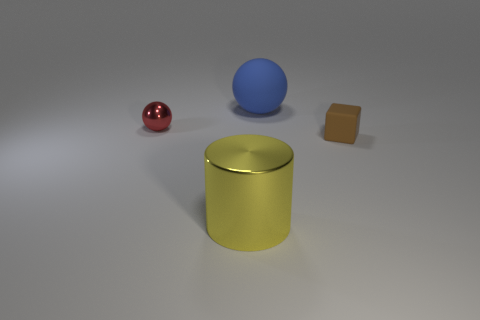What number of metal things are either big blue spheres or big yellow objects?
Your answer should be compact. 1. There is a sphere that is on the right side of the metal object behind the tiny block; what is it made of?
Provide a short and direct response. Rubber. What is the size of the yellow metal object?
Provide a short and direct response. Large. How many yellow shiny objects are the same size as the blue thing?
Your answer should be compact. 1. How many yellow things are the same shape as the brown thing?
Provide a succinct answer. 0. Is the number of large yellow shiny objects in front of the cylinder the same as the number of metallic spheres?
Ensure brevity in your answer.  No. Is there any other thing that has the same size as the blue matte thing?
Offer a terse response. Yes. What shape is the blue object that is the same size as the yellow cylinder?
Keep it short and to the point. Sphere. Is there a large green thing of the same shape as the small brown rubber object?
Your answer should be very brief. No. Are there any brown rubber blocks in front of the tiny object that is to the right of the large thing that is in front of the red metallic thing?
Your response must be concise. No. 